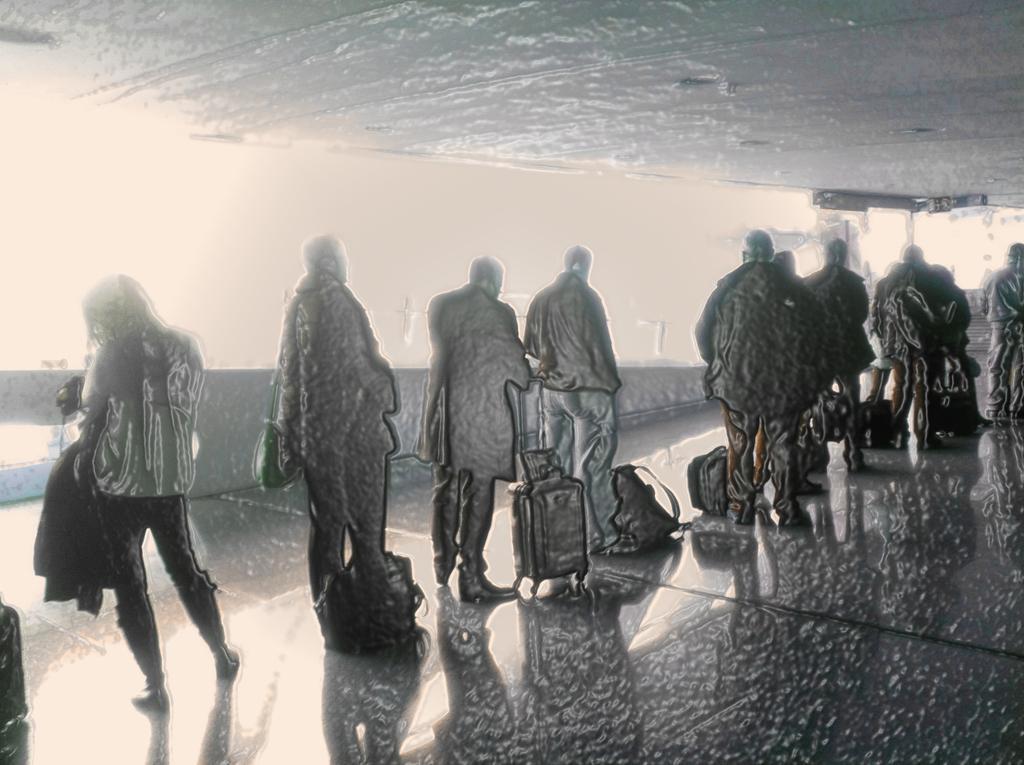In one or two sentences, can you explain what this image depicts? In the image I can see edited picture. In which I can see few people, bags and floor. 